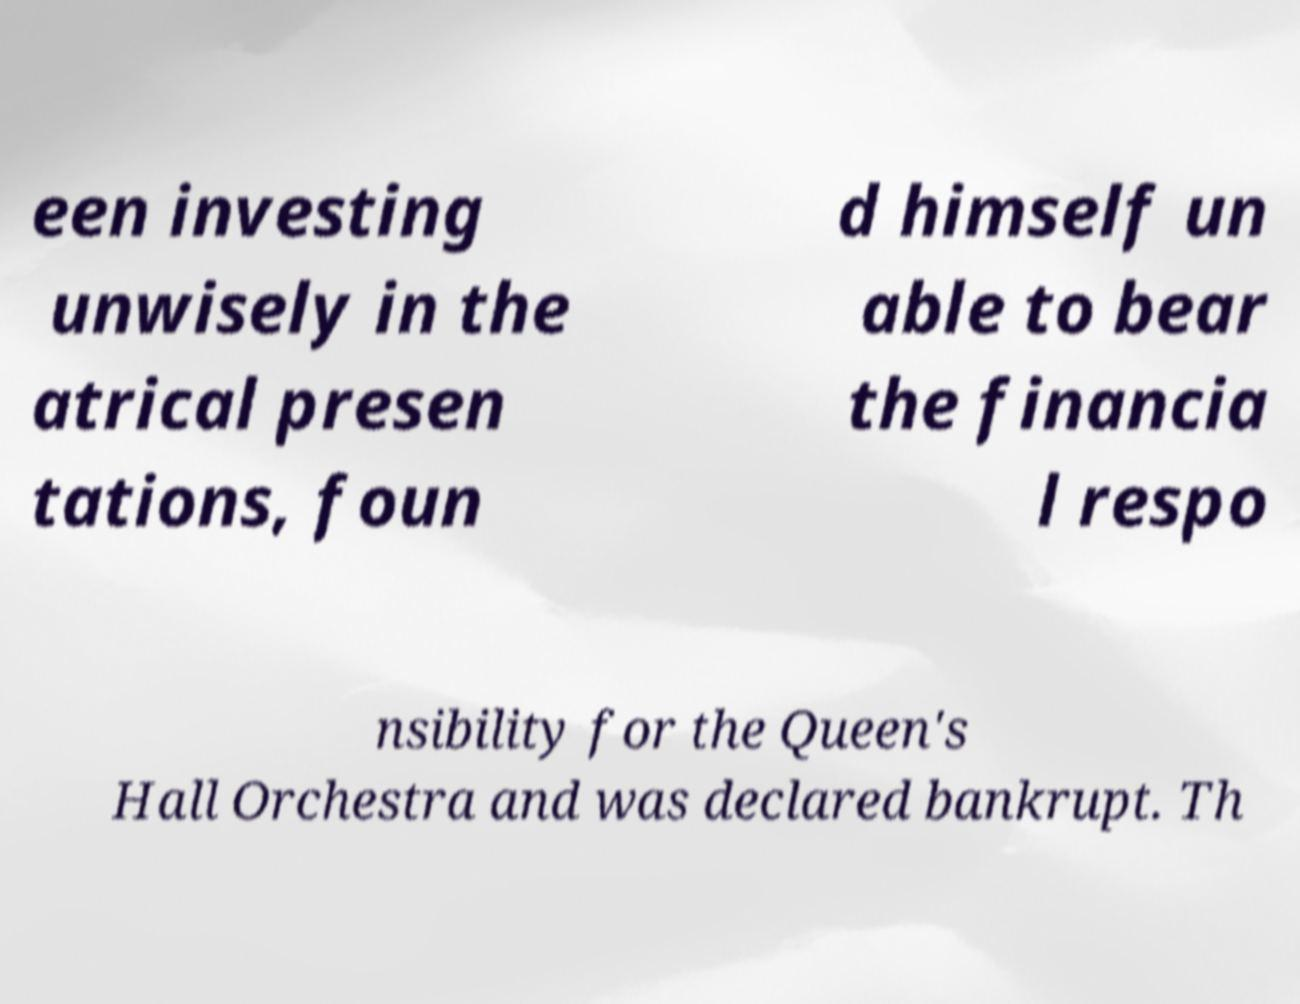Could you assist in decoding the text presented in this image and type it out clearly? een investing unwisely in the atrical presen tations, foun d himself un able to bear the financia l respo nsibility for the Queen's Hall Orchestra and was declared bankrupt. Th 